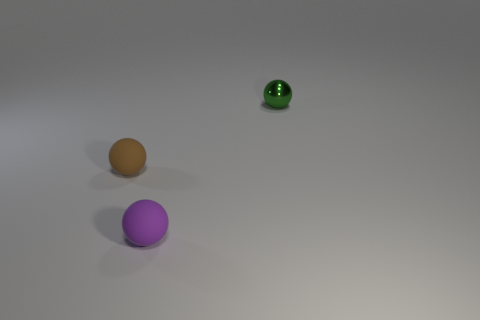What is the material of the small brown object that is the same shape as the green object?
Your answer should be very brief. Rubber. What number of objects are balls in front of the small shiny ball or balls?
Give a very brief answer. 3. How many small green things have the same shape as the tiny brown matte object?
Make the answer very short. 1. What is the tiny purple ball made of?
Your answer should be compact. Rubber. Does the small metallic thing have the same color as the ball that is in front of the small brown sphere?
Provide a short and direct response. No. How many balls are small shiny things or small brown things?
Your response must be concise. 2. The tiny sphere that is left of the small purple ball is what color?
Give a very brief answer. Brown. What number of other balls are the same size as the green metal sphere?
Ensure brevity in your answer.  2. Do the tiny thing right of the tiny purple rubber object and the rubber object on the left side of the purple thing have the same shape?
Make the answer very short. Yes. There is a object in front of the tiny matte ball behind the small matte ball that is right of the brown rubber ball; what is its material?
Provide a short and direct response. Rubber. 